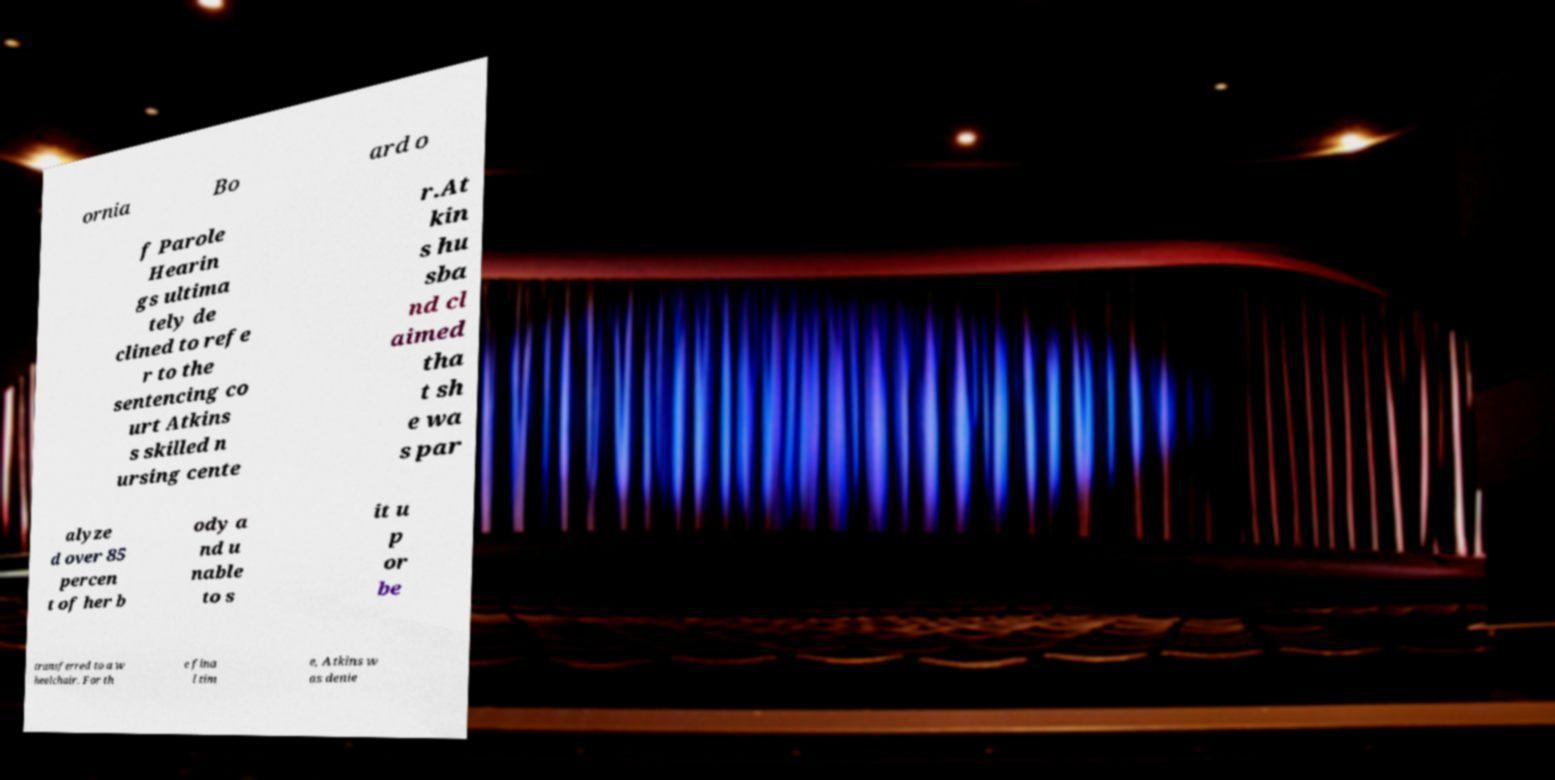Can you read and provide the text displayed in the image?This photo seems to have some interesting text. Can you extract and type it out for me? ornia Bo ard o f Parole Hearin gs ultima tely de clined to refe r to the sentencing co urt Atkins s skilled n ursing cente r.At kin s hu sba nd cl aimed tha t sh e wa s par alyze d over 85 percen t of her b ody a nd u nable to s it u p or be transferred to a w heelchair. For th e fina l tim e, Atkins w as denie 